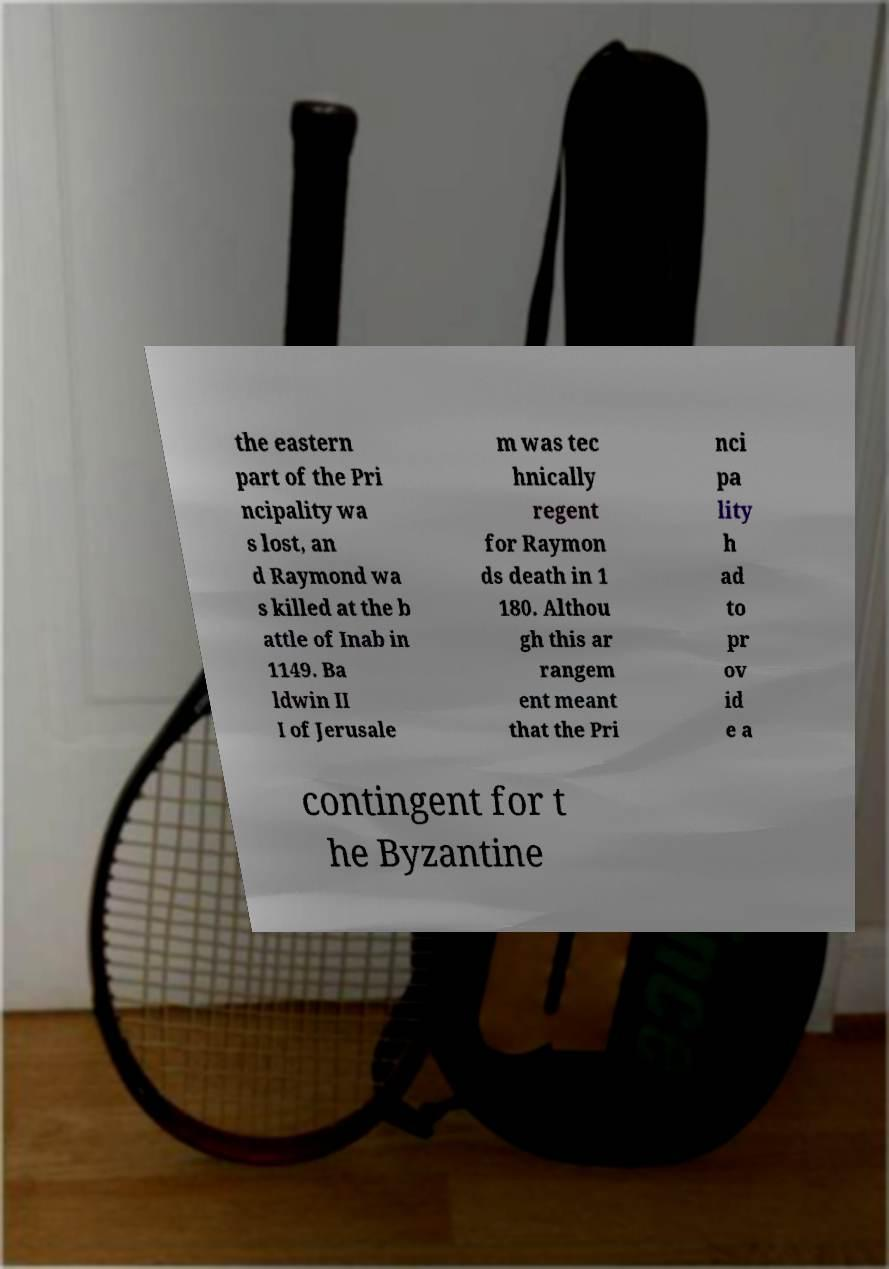For documentation purposes, I need the text within this image transcribed. Could you provide that? the eastern part of the Pri ncipality wa s lost, an d Raymond wa s killed at the b attle of Inab in 1149. Ba ldwin II I of Jerusale m was tec hnically regent for Raymon ds death in 1 180. Althou gh this ar rangem ent meant that the Pri nci pa lity h ad to pr ov id e a contingent for t he Byzantine 